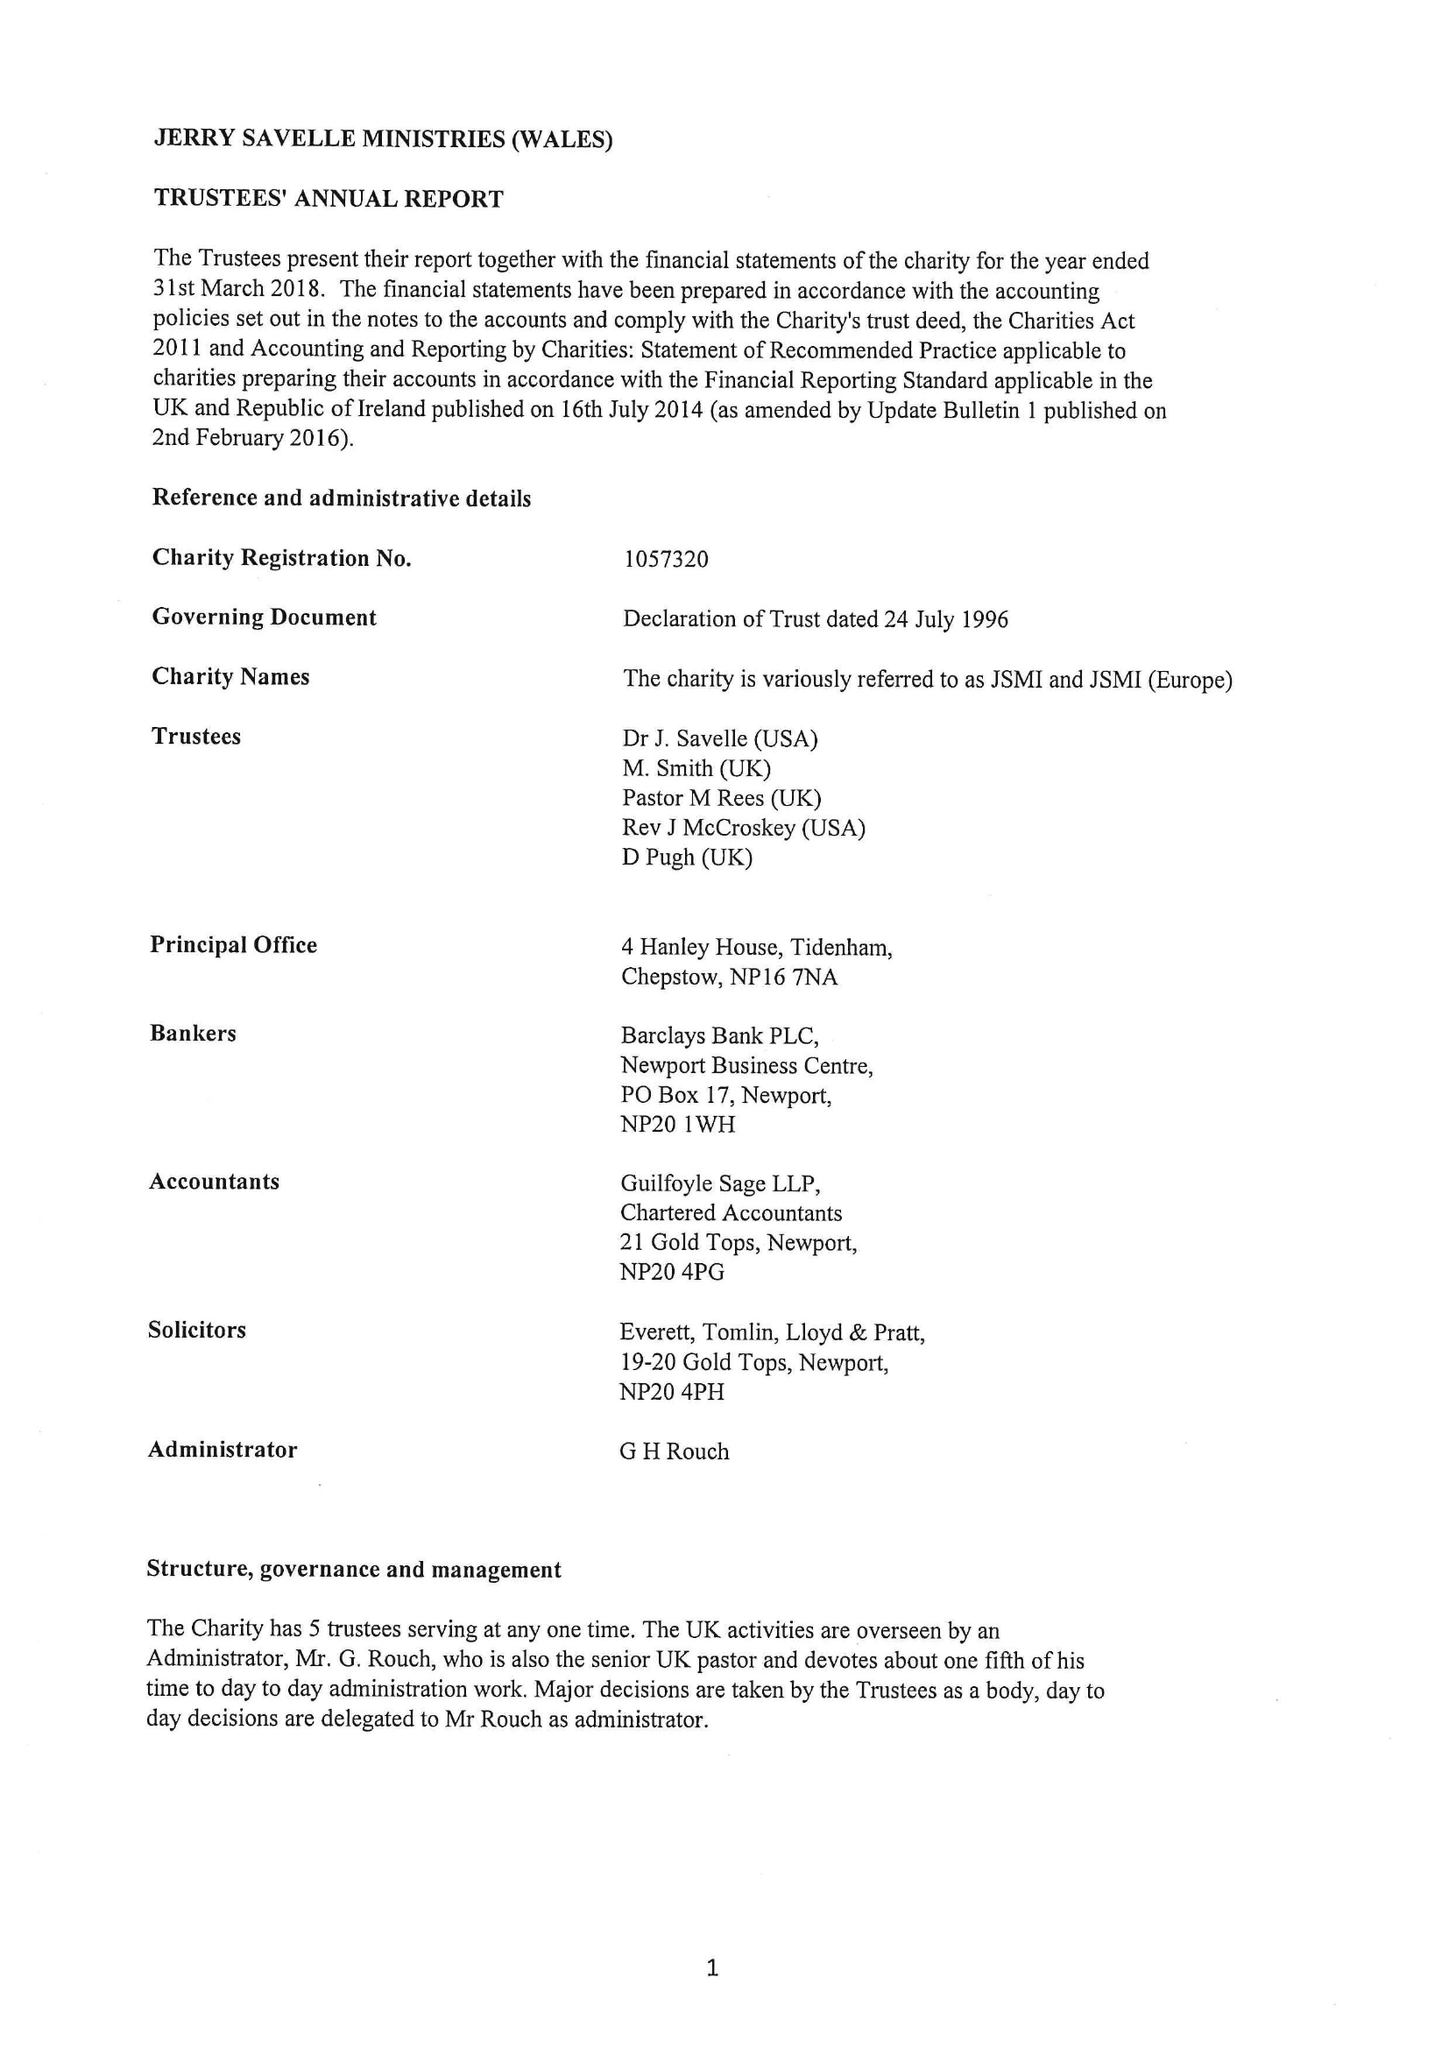What is the value for the address__postcode?
Answer the question using a single word or phrase. NP16 7NA 